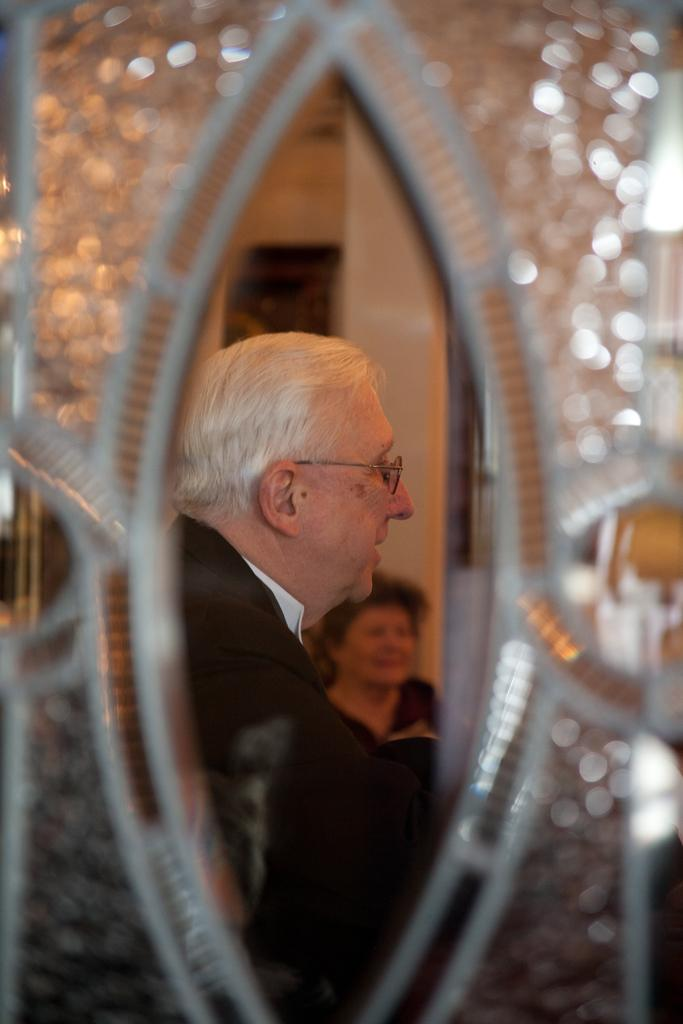What object is present in the image that can be used for reflection? There is a mirror in the image. Who is looking at the mirror in the image? An old man is looking at the mirror. What is the old man wearing in the image? The old man is wearing a black color coat. Does the old man have any accessories in the image? Yes, the old man is wearing spectacles. What type of orange fruit can be seen in the image? There is no orange fruit present in the image. What kind of art is displayed on the wall in the image? There is no art displayed on the wall in the image. 